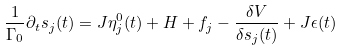<formula> <loc_0><loc_0><loc_500><loc_500>\frac { 1 } { \Gamma _ { 0 } } \partial _ { t } s _ { j } ( t ) = J \eta ^ { 0 } _ { j } ( t ) + H + f _ { j } - \frac { \delta V } { \delta s _ { j } ( t ) } + J \epsilon ( t )</formula> 